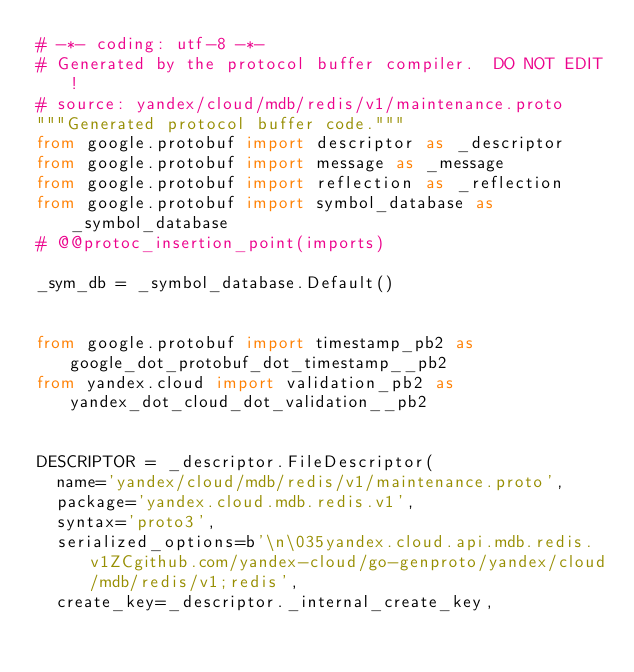<code> <loc_0><loc_0><loc_500><loc_500><_Python_># -*- coding: utf-8 -*-
# Generated by the protocol buffer compiler.  DO NOT EDIT!
# source: yandex/cloud/mdb/redis/v1/maintenance.proto
"""Generated protocol buffer code."""
from google.protobuf import descriptor as _descriptor
from google.protobuf import message as _message
from google.protobuf import reflection as _reflection
from google.protobuf import symbol_database as _symbol_database
# @@protoc_insertion_point(imports)

_sym_db = _symbol_database.Default()


from google.protobuf import timestamp_pb2 as google_dot_protobuf_dot_timestamp__pb2
from yandex.cloud import validation_pb2 as yandex_dot_cloud_dot_validation__pb2


DESCRIPTOR = _descriptor.FileDescriptor(
  name='yandex/cloud/mdb/redis/v1/maintenance.proto',
  package='yandex.cloud.mdb.redis.v1',
  syntax='proto3',
  serialized_options=b'\n\035yandex.cloud.api.mdb.redis.v1ZCgithub.com/yandex-cloud/go-genproto/yandex/cloud/mdb/redis/v1;redis',
  create_key=_descriptor._internal_create_key,</code> 